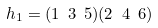Convert formula to latex. <formula><loc_0><loc_0><loc_500><loc_500>h _ { 1 } = ( 1 \ 3 \ 5 ) ( 2 \ 4 \ 6 )</formula> 